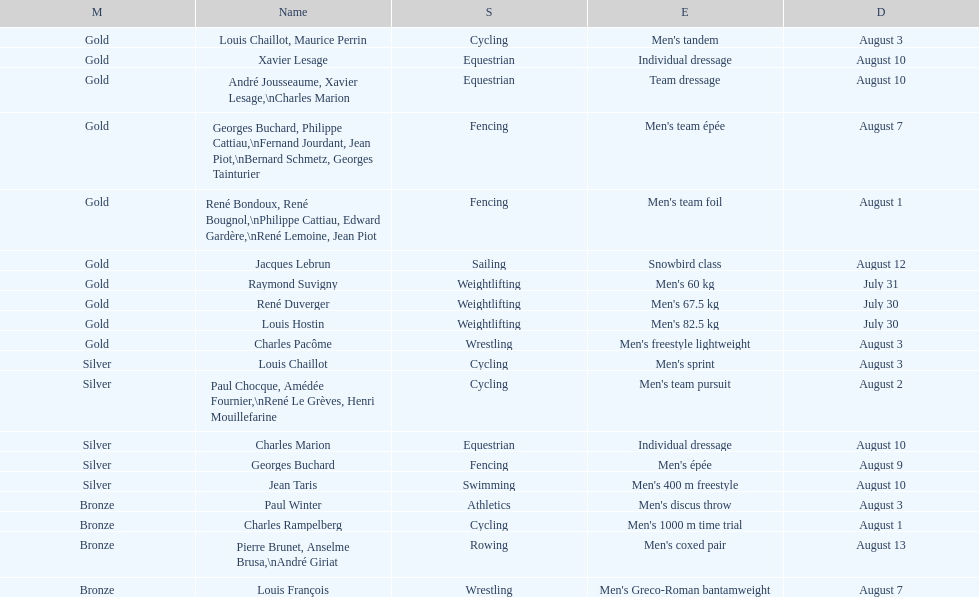Was there more gold medals won than silver? Yes. 